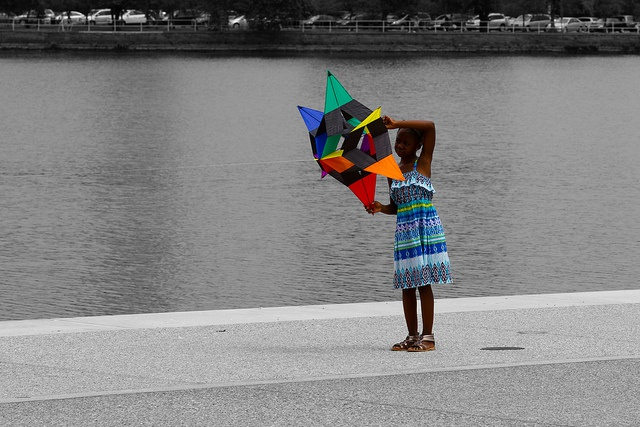Describe the objects in this image and their specific colors. I can see people in black, darkgray, gray, and navy tones, kite in black, brown, red, and navy tones, car in black, gray, darkgray, and gainsboro tones, car in black, gray, darkgray, and lightgray tones, and car in black, gray, darkgray, and lightgray tones in this image. 